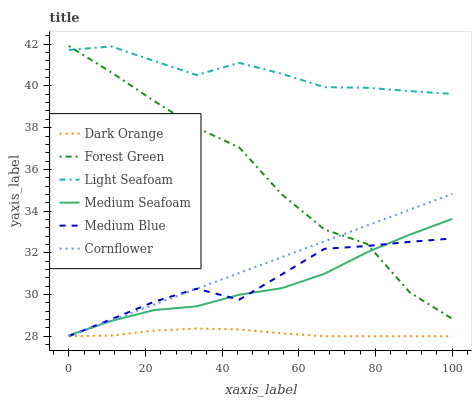Does Dark Orange have the minimum area under the curve?
Answer yes or no. Yes. Does Light Seafoam have the maximum area under the curve?
Answer yes or no. Yes. Does Cornflower have the minimum area under the curve?
Answer yes or no. No. Does Cornflower have the maximum area under the curve?
Answer yes or no. No. Is Cornflower the smoothest?
Answer yes or no. Yes. Is Forest Green the roughest?
Answer yes or no. Yes. Is Medium Blue the smoothest?
Answer yes or no. No. Is Medium Blue the roughest?
Answer yes or no. No. Does Forest Green have the lowest value?
Answer yes or no. No. Does Cornflower have the highest value?
Answer yes or no. No. Is Medium Blue less than Light Seafoam?
Answer yes or no. Yes. Is Light Seafoam greater than Dark Orange?
Answer yes or no. Yes. Does Medium Blue intersect Light Seafoam?
Answer yes or no. No. 